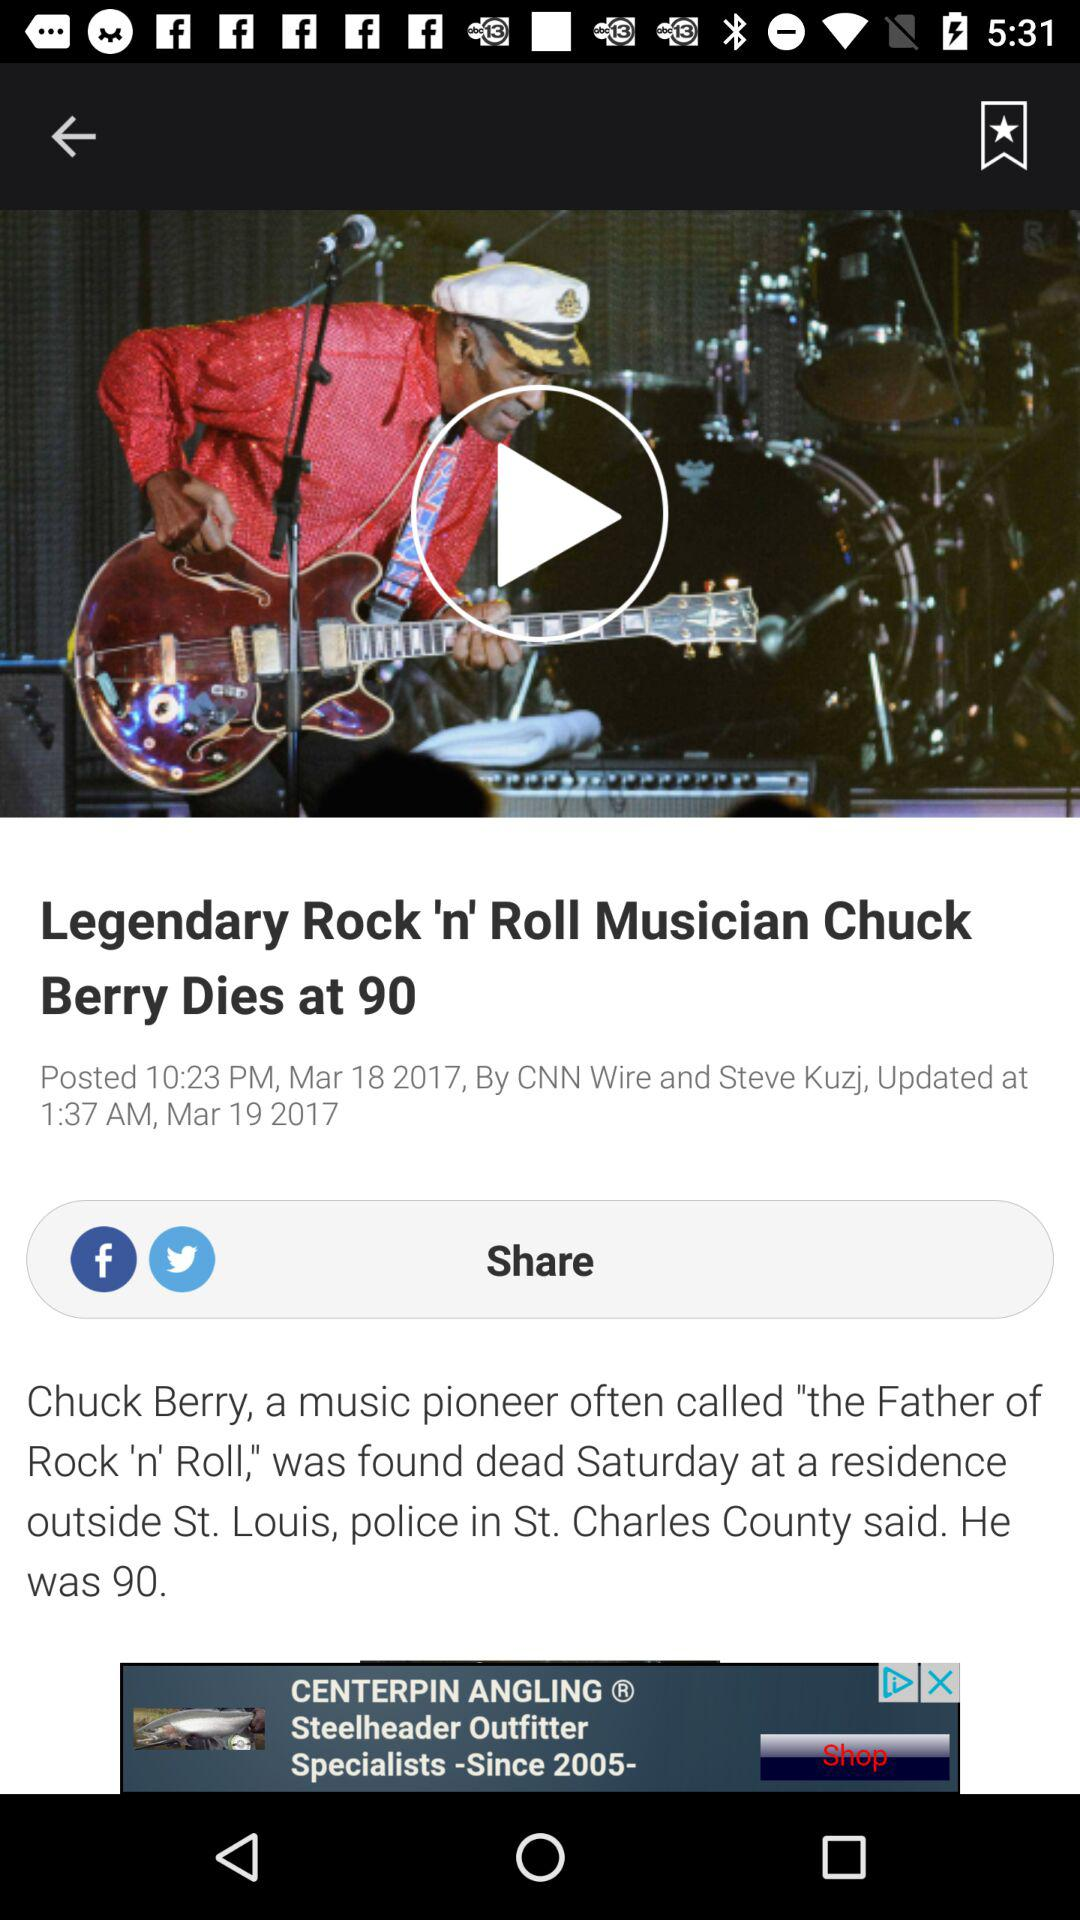When was the news updated? The news was updated on March 19, 2017 at 1:37 a.m. 